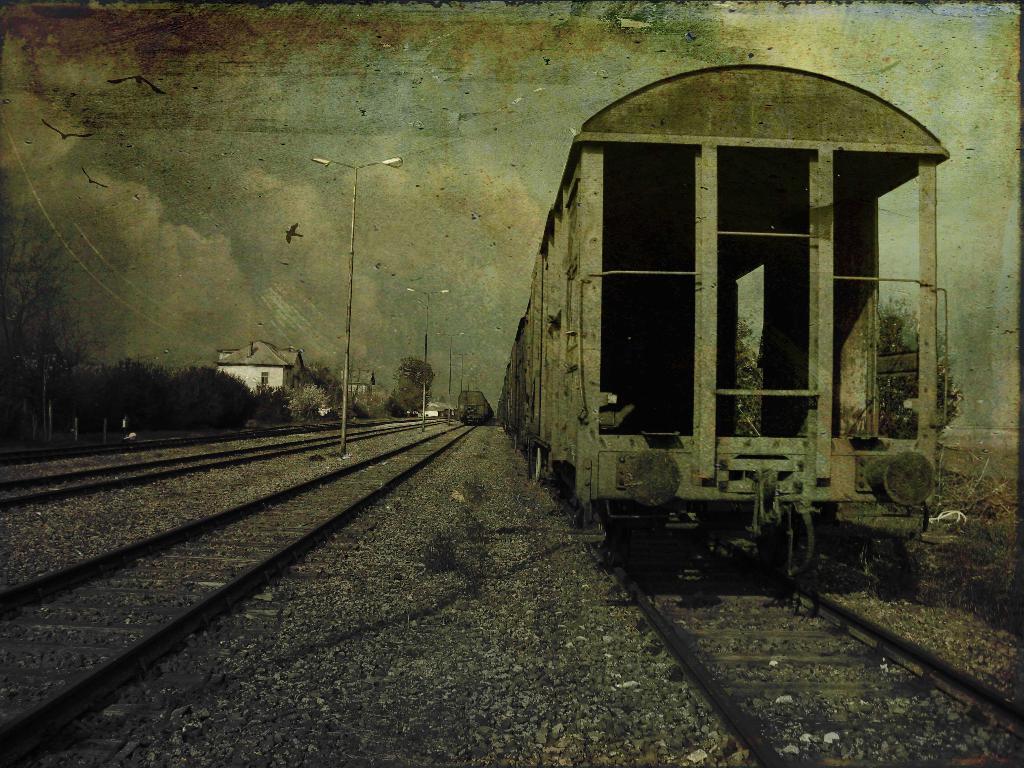Could you give a brief overview of what you see in this image? Here in this picture we can see a train present on a railway track over there and beside that also we can see other railway tracks present over there and we can see light posts present all over there and we can see trees and plants here and there and we can also see buildings in the far and we can see clouds in sky and we can also see birds flying in the air over there. 